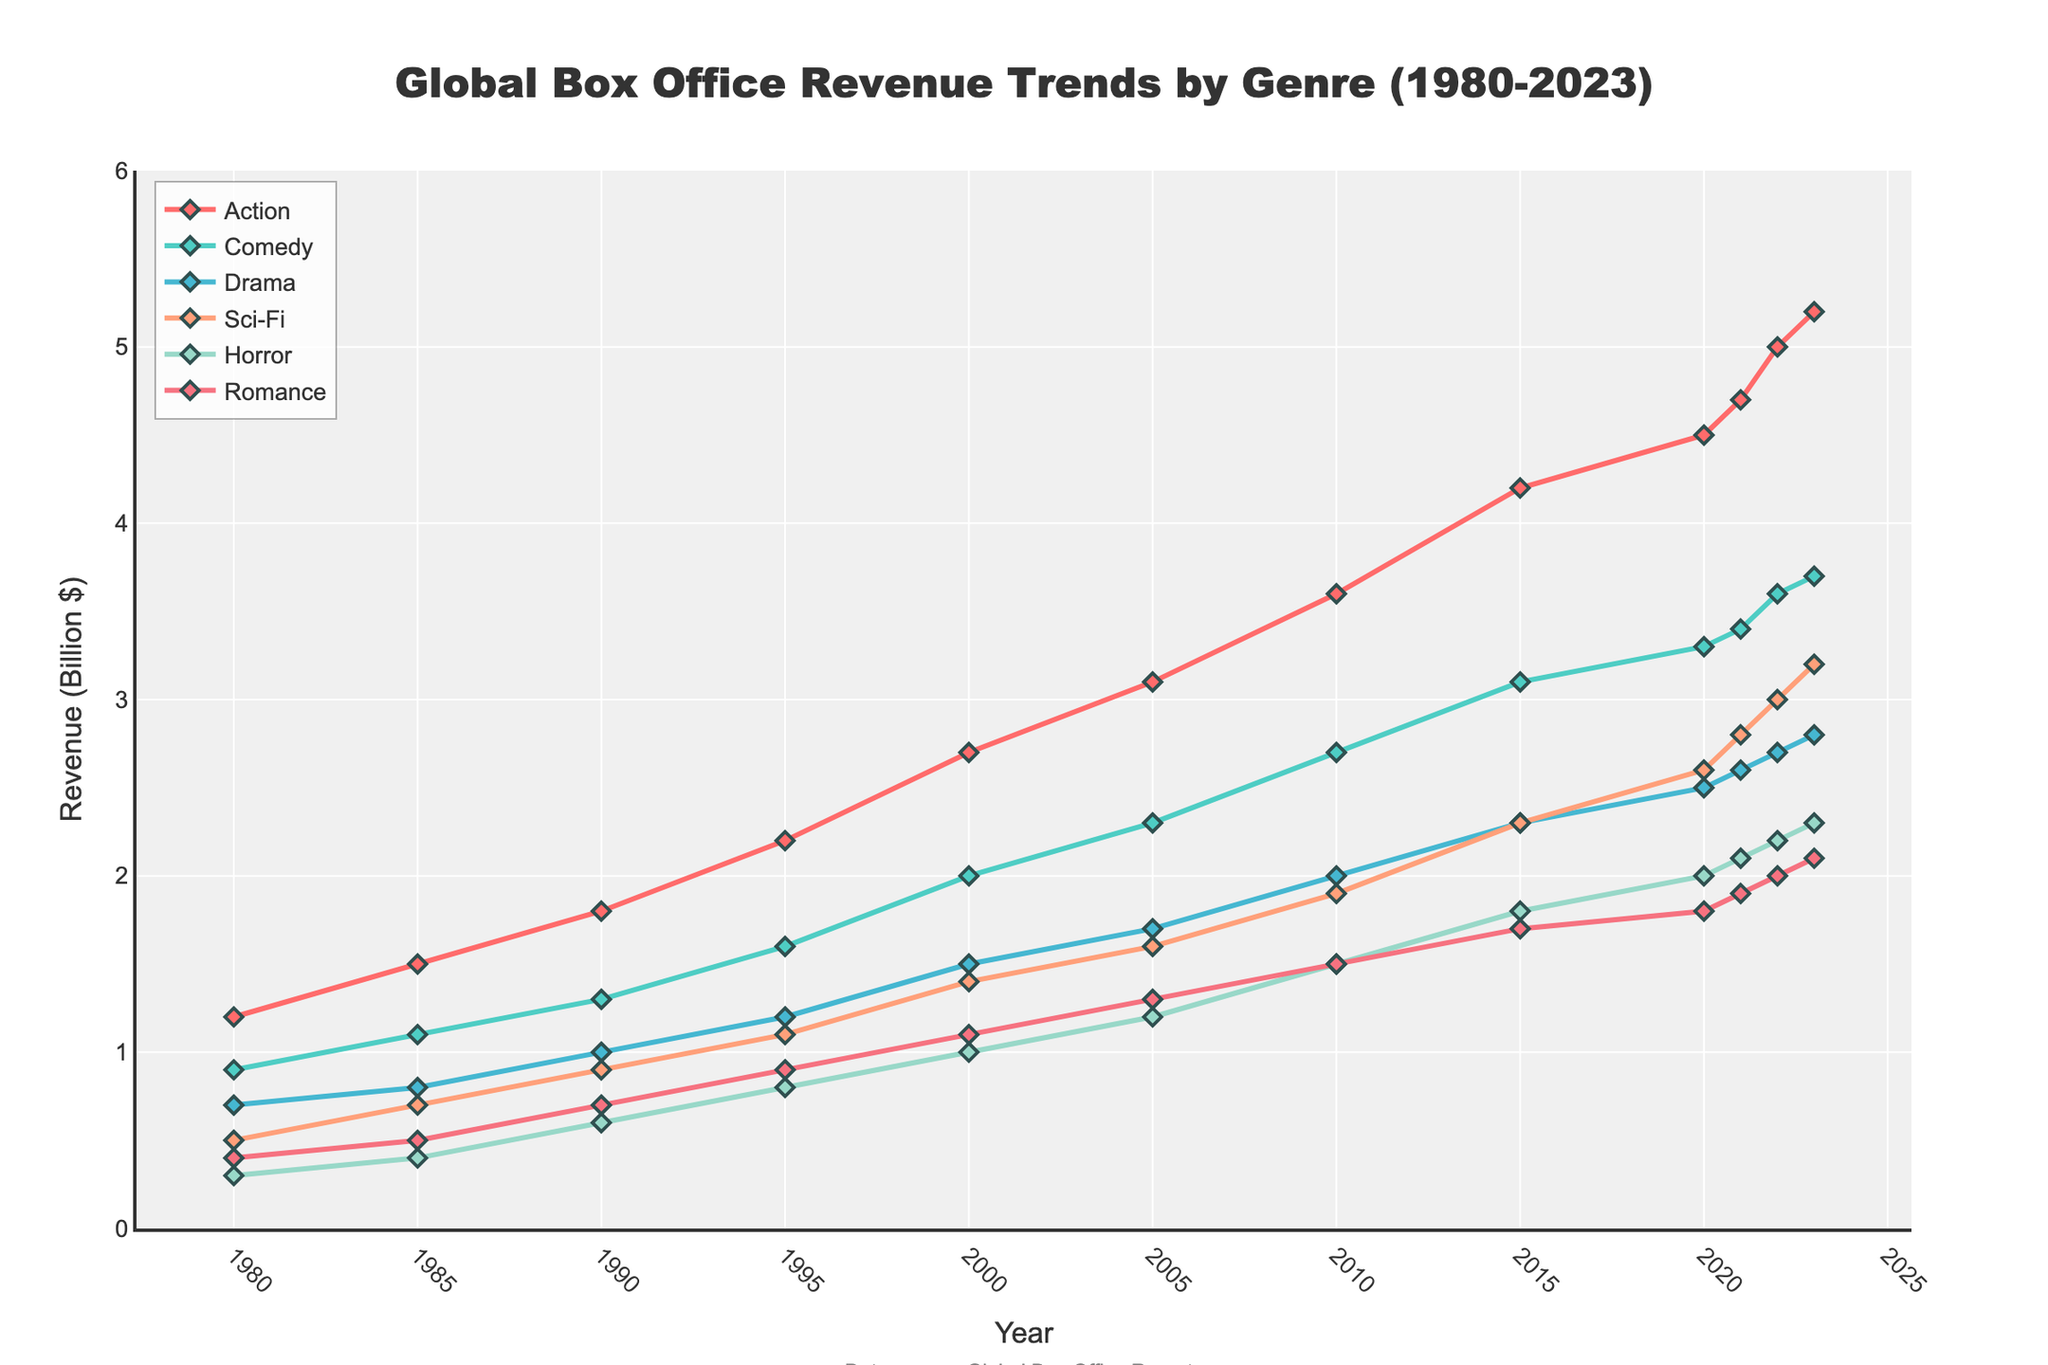Which genre had the highest box office revenue in 2023? By inspecting the highest points across all lines in 2023, the genre with the highest revenue is the one with the peak closest to the value on the y-axis. For 2023, Action reaches the highest point.
Answer: Action Which genre saw the steepest increase in revenue from 1980 to 2023? For this, we need to find which line has the largest vertical distance between its 1980 point and its 2023 point. Action has the highest increase from 1.2 in 1980 to 5.2 in 2023, making it the genre with the steepest increase.
Answer: Action What is the revenue difference between Sci-Fi and Horror in 2020? To find the difference, we take the value for Sci-Fi and subtract the value for Horror in 2020. Sci-Fi has 2.6 and Horror has 2.0, so the difference is 2.6 - 2.0.
Answer: 0.6 How did the revenue for Comedy compare to Romance in 2000? By comparing the heights of the points on the Comedy and Romance lines in 2000, Comedy is at 2.0 and Romance is at 1.1, making Comedy higher than Romance.
Answer: Higher Which genre had the lowest revenue in 1980 and how much was it? By inspecting the lowest point on the graph for 1980, Horror is at the bottom with a value of 0.3.
Answer: Horror, 0.3 What is the average revenue of the Drama genre over the entire period? Take the values of Drama across all years, sum them and divide by the number of data points: (0.7 + 0.8 + 1.0 + 1.2 + 1.5 + 1.7 + 2.0 + 2.3 + 2.5 + 2.6 + 2.7 + 2.8) / 12 = 1.7
Answer: 1.7 What is the revenue trend comparison between Sci-Fi and Comedy from 1980 to 2023? By comparing the slopes of the lines, Sci-Fi starts at a lower value (0.5 in 1980) and ends closer to Comedy (3.2 vs. 3.7 in 2023). Sci-Fi has a sharper rise relative to its starting point, but Comedy consistently remains higher.
Answer: Sci-Fi increased more steeply How much did the revenue for Horror increase from 1990 to 2023? Subtract the revenue value of Horror in 1990 from that in 2023: 2.3 - 0.6 = 1.7
Answer: 1.7 Which genre's revenue experienced the least change from 2000 to 2023? By comparing differences in revenue from 2000 to 2023 across all genres, Romance saw the smallest change, from 1.1 to 2.1, a difference of 1.0.
Answer: Romance 